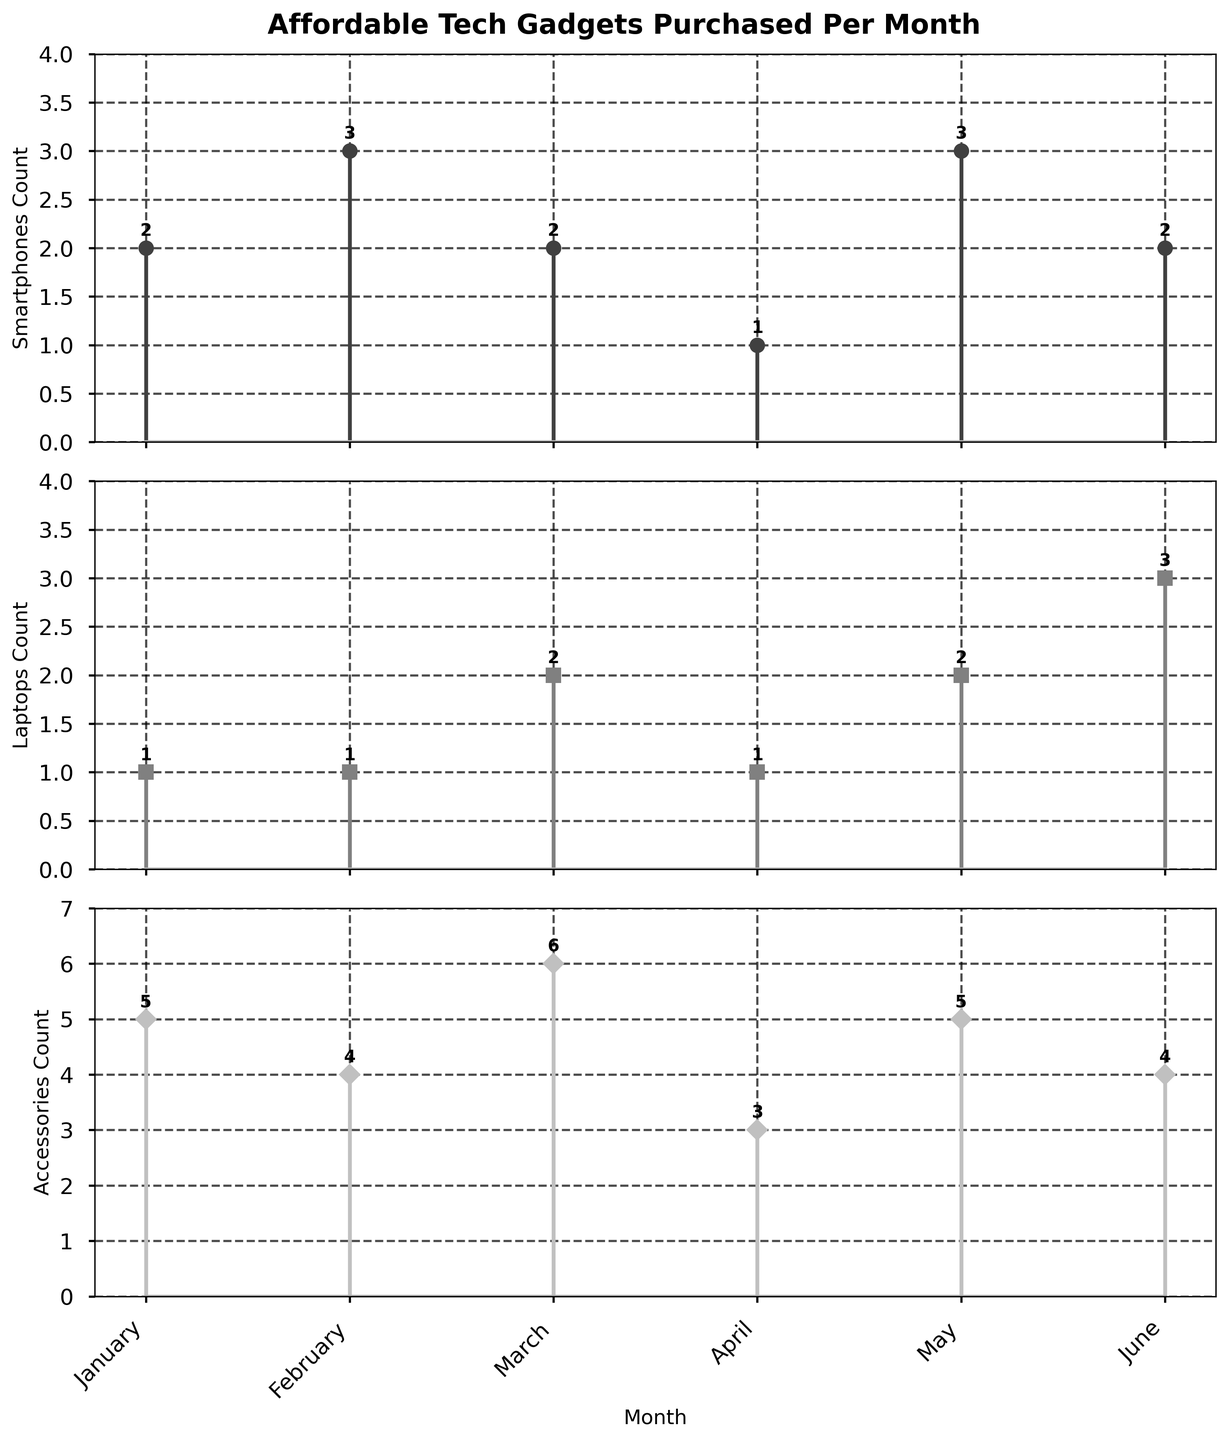How many types of tech gadgets are represented in the figure? There are three subplots in the figure, each representing a different type of tech gadget: Smartphones, Laptops, and Accessories.
Answer: 3 What is the title of the figure? The title is found at the top of the figure.
Answer: Affordable Tech Gadgets Purchased Per Month Which type of tech gadget had the highest count in January? By looking at the three subplots for January, Accessories have the highest count (5) compared to Smartphones (2) and Laptops (1).
Answer: Accessories How many smartphones were purchased in total over the given months? Sum the counts of smartphones for each month: 2 (January) + 3 (February) + 2 (March) + 1 (April) + 3 (May) + 2 (June) = 13
Answer: 13 Which month had the lowest count for laptops? Look at the subplot for Laptops and find the smallest count, which is 1 in both January, February, and April.
Answer: January, February, and April What is the average monthly purchase count of accessories? Sum the counts of accessories and divide by the number of months: (5 + 4 + 6 + 3 + 5 + 4) / 6 = 27 / 6 = 4.5
Answer: 4.5 In which month were the most tech gadgets purchased overall? Add the counts of all types for each month and find the month with the highest total. January: 2+1+5=8, February: 3+1+4=8, March: 2+2+6=10, April: 1+1+3=5, May: 3+2+5=10, June: 2+3+4=9. March and May both have the highest total (10).
Answer: March and May How did the number of laptops purchased in May compare to the number in June? Compare the counts for May (2) and June (3) in the Laptops subplot.
Answer: Less in May What trend can you observe in the number of accessories purchased from January to June? Observe the counts in the Accessories subplot across the months: 5 (Jan), 4 (Feb), 6 (Mar), 3 (Apr), 5 (May), 4 (Jun). It fluctuates but there is no clear increasing or decreasing trend.
Answer: Fluctuating Are there any months where the counts for all tech gadgets were equal? Compare counts for each tech gadget type across all months. There are no months where all counts (Smartphones, Laptops, Accessories) are equal.
Answer: No 